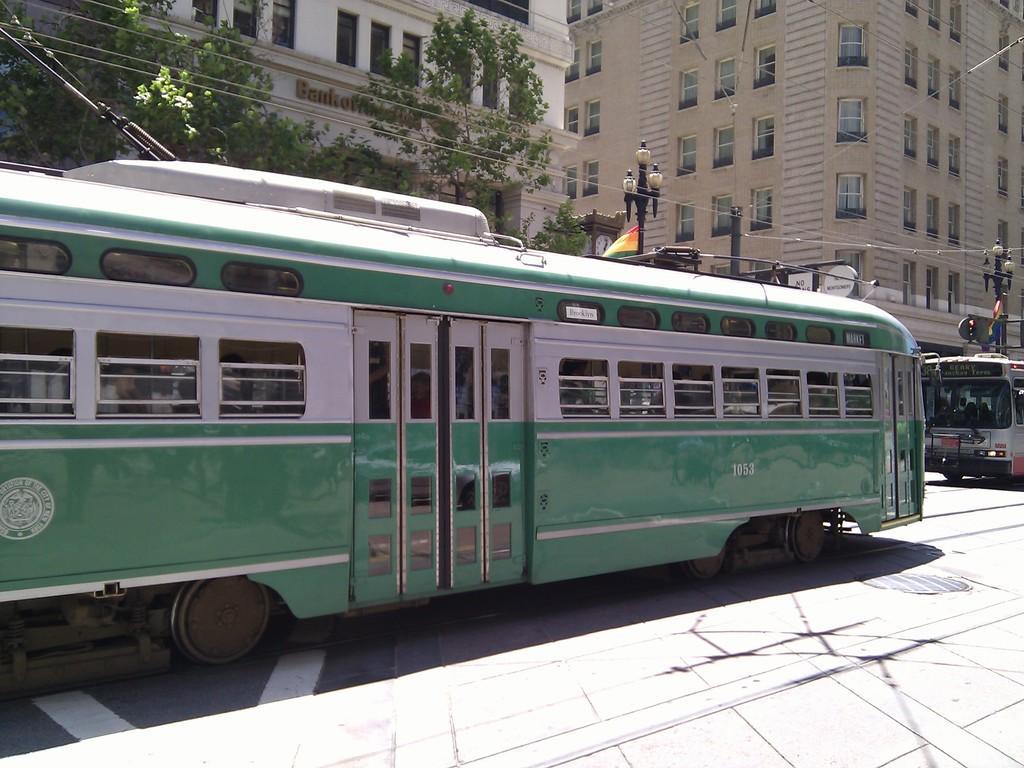Could you give a brief overview of what you see in this image? In this picture there is a bus in the center of the image and there is another bus on the right side of the image, there are buildings, trees, and poles in the background area of the image. 